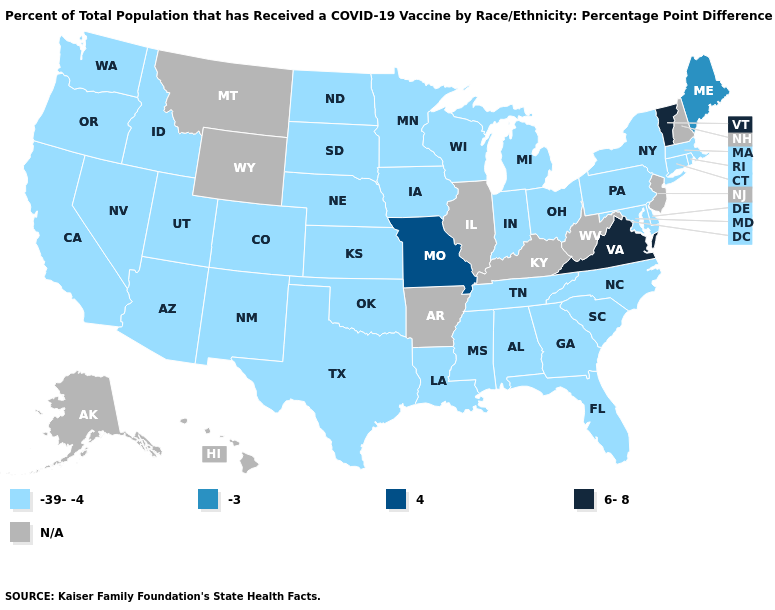Which states have the lowest value in the USA?
Keep it brief. Alabama, Arizona, California, Colorado, Connecticut, Delaware, Florida, Georgia, Idaho, Indiana, Iowa, Kansas, Louisiana, Maryland, Massachusetts, Michigan, Minnesota, Mississippi, Nebraska, Nevada, New Mexico, New York, North Carolina, North Dakota, Ohio, Oklahoma, Oregon, Pennsylvania, Rhode Island, South Carolina, South Dakota, Tennessee, Texas, Utah, Washington, Wisconsin. What is the value of Louisiana?
Short answer required. -39--4. Is the legend a continuous bar?
Write a very short answer. No. Does Vermont have the highest value in the USA?
Concise answer only. Yes. Among the states that border Wisconsin , which have the lowest value?
Short answer required. Iowa, Michigan, Minnesota. Among the states that border Illinois , does Missouri have the lowest value?
Write a very short answer. No. Does the map have missing data?
Give a very brief answer. Yes. Name the states that have a value in the range N/A?
Concise answer only. Alaska, Arkansas, Hawaii, Illinois, Kentucky, Montana, New Hampshire, New Jersey, West Virginia, Wyoming. Which states have the lowest value in the MidWest?
Keep it brief. Indiana, Iowa, Kansas, Michigan, Minnesota, Nebraska, North Dakota, Ohio, South Dakota, Wisconsin. 